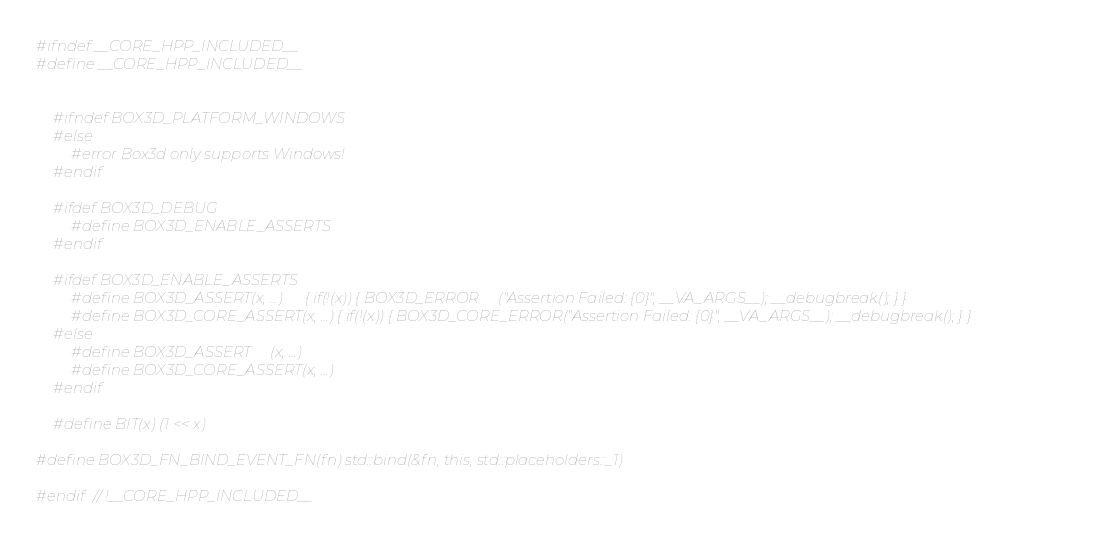<code> <loc_0><loc_0><loc_500><loc_500><_C++_>#ifndef __CORE_HPP_INCLUDED__
#define __CORE_HPP_INCLUDED__


    #ifndef BOX3D_PLATFORM_WINDOWS
    #else
        #error Box3d only supports Windows!
    #endif

    #ifdef BOX3D_DEBUG
        #define BOX3D_ENABLE_ASSERTS
    #endif

    #ifdef BOX3D_ENABLE_ASSERTS
        #define BOX3D_ASSERT(x, ...)      { if(!(x)) { BOX3D_ERROR     ("Assertion Failed: {0}", __VA_ARGS__); __debugbreak(); } }
        #define BOX3D_CORE_ASSERT(x, ...) { if(!(x)) { BOX3D_CORE_ERROR("Assertion Failed: {0}", __VA_ARGS__); __debugbreak(); } }
    #else
        #define BOX3D_ASSERT     (x, ...)
        #define BOX3D_CORE_ASSERT(x, ...)
    #endif
    
    #define BIT(x) (1 << x)

#define BOX3D_FN_BIND_EVENT_FN(fn) std::bind(&fn, this, std::placeholders::_1)

#endif // !__CORE_HPP_INCLUDED__
</code> 